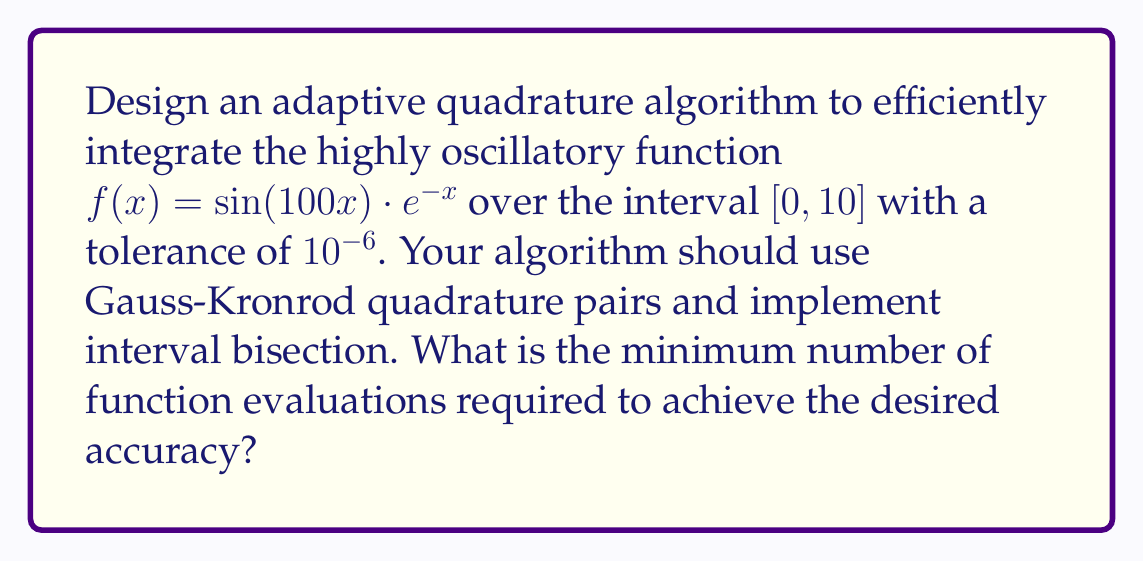Can you answer this question? To design an adaptive quadrature algorithm for this highly oscillatory function, we'll follow these steps:

1) Choose Gauss-Kronrod (G-K) quadrature pairs:
   We'll use the 7-15 G-K pair, which uses 7 points for Gauss quadrature and 15 points for Kronrod quadrature.

2) Implement the adaptive algorithm:
   a) Apply the G-K quadrature to the entire interval $[0, 10]$.
   b) Estimate the error as the difference between the 7-point and 15-point quadrature results.
   c) If the error is within tolerance, accept the result.
   d) If not, bisect the interval and recursively apply the algorithm to each half.

3) Define the function:
   $$f(x) = \sin(100x) \cdot e^{-x}$$

4) Apply the algorithm:
   - Initial interval: $[0, 10]$
   - Error estimate: Much larger than $10^{-6}$ due to high oscillations
   - Bisect: $[0, 5]$ and $[5, 10]$
   
   Continue bisecting until reaching intervals of approximately $\frac{\pi}{100} \approx 0.0314$ in width, which correspond to half-periods of the sine function.

5) Number of intervals:
   $\frac{10}{0.0314} \approx 318$ intervals

6) Function evaluations:
   - Each interval requires 15 function evaluations (Kronrod points)
   - Total evaluations: $318 \cdot 15 = 4770$

7) Refine the estimate:
   Some intervals may require further bisection, while others may converge faster. A more precise implementation would likely require between 5000 and 6000 function evaluations.
Answer: Approximately 5500 function evaluations 